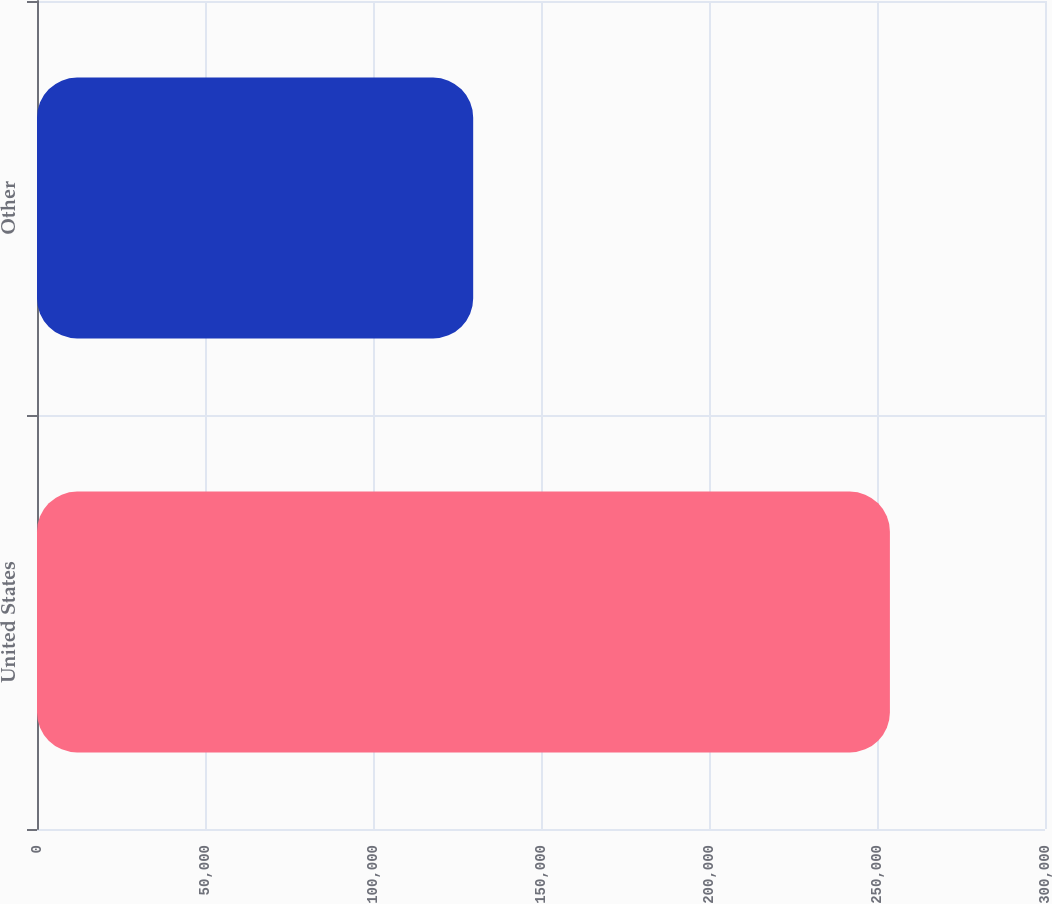<chart> <loc_0><loc_0><loc_500><loc_500><bar_chart><fcel>United States<fcel>Other<nl><fcel>253841<fcel>129816<nl></chart> 